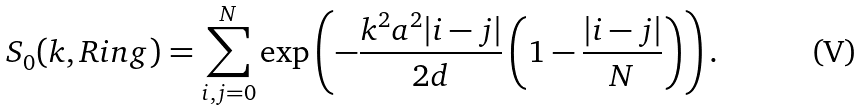<formula> <loc_0><loc_0><loc_500><loc_500>S _ { 0 } ( { k } , R i n g ) = \sum _ { i , j = 0 } ^ { N } \exp \left ( - \frac { k ^ { 2 } a ^ { 2 } | i - j | } { 2 d } \left ( 1 - \frac { | i - j | } { N } \right ) \right ) .</formula> 